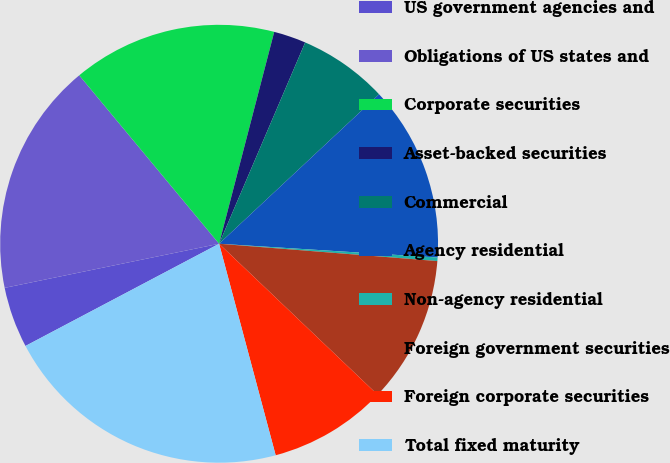<chart> <loc_0><loc_0><loc_500><loc_500><pie_chart><fcel>US government agencies and<fcel>Obligations of US states and<fcel>Corporate securities<fcel>Asset-backed securities<fcel>Commercial<fcel>Agency residential<fcel>Non-agency residential<fcel>Foreign government securities<fcel>Foreign corporate securities<fcel>Total fixed maturity<nl><fcel>4.5%<fcel>17.2%<fcel>15.08%<fcel>2.38%<fcel>6.61%<fcel>12.96%<fcel>0.26%<fcel>10.85%<fcel>8.73%<fcel>21.43%<nl></chart> 